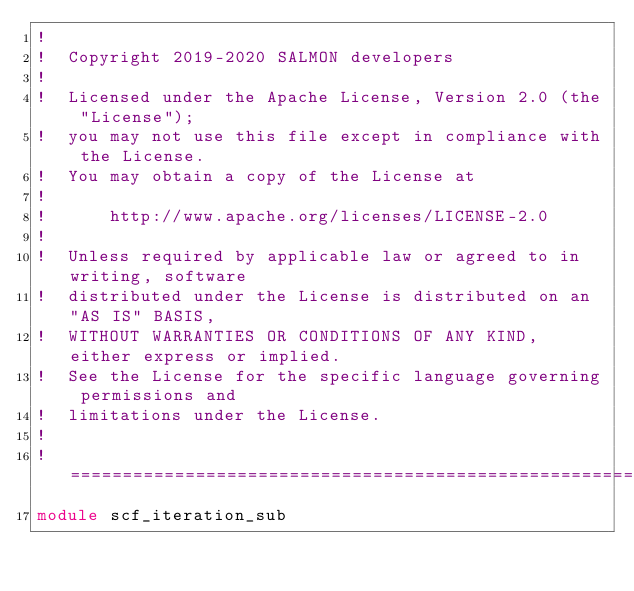Convert code to text. <code><loc_0><loc_0><loc_500><loc_500><_FORTRAN_>!
!  Copyright 2019-2020 SALMON developers
!
!  Licensed under the Apache License, Version 2.0 (the "License");
!  you may not use this file except in compliance with the License.
!  You may obtain a copy of the License at
!
!      http://www.apache.org/licenses/LICENSE-2.0
!
!  Unless required by applicable law or agreed to in writing, software
!  distributed under the License is distributed on an "AS IS" BASIS,
!  WITHOUT WARRANTIES OR CONDITIONS OF ANY KIND, either express or implied.
!  See the License for the specific language governing permissions and
!  limitations under the License.
!
!=======================================================================
module scf_iteration_sub</code> 